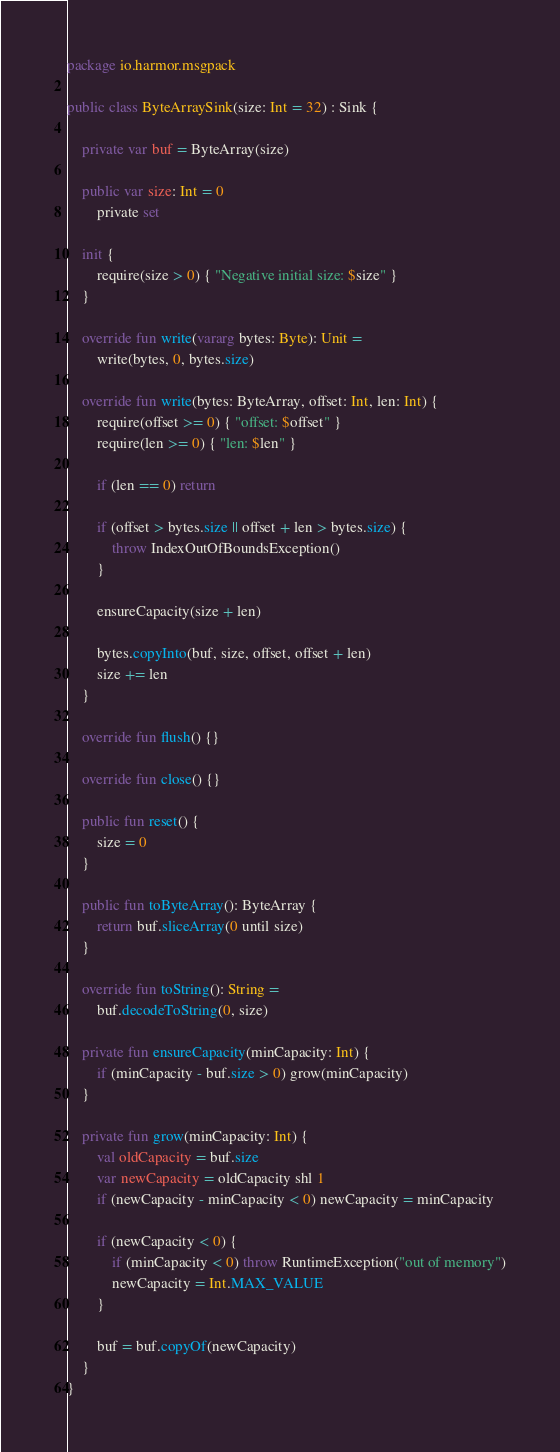<code> <loc_0><loc_0><loc_500><loc_500><_Kotlin_>package io.harmor.msgpack

public class ByteArraySink(size: Int = 32) : Sink {

    private var buf = ByteArray(size)

    public var size: Int = 0
        private set

    init {
        require(size > 0) { "Negative initial size: $size" }
    }

    override fun write(vararg bytes: Byte): Unit =
        write(bytes, 0, bytes.size)

    override fun write(bytes: ByteArray, offset: Int, len: Int) {
        require(offset >= 0) { "offset: $offset" }
        require(len >= 0) { "len: $len" }

        if (len == 0) return

        if (offset > bytes.size || offset + len > bytes.size) {
            throw IndexOutOfBoundsException()
        }

        ensureCapacity(size + len)

        bytes.copyInto(buf, size, offset, offset + len)
        size += len
    }

    override fun flush() {}

    override fun close() {}

    public fun reset() {
        size = 0
    }

    public fun toByteArray(): ByteArray {
        return buf.sliceArray(0 until size)
    }

    override fun toString(): String =
        buf.decodeToString(0, size)

    private fun ensureCapacity(minCapacity: Int) {
        if (minCapacity - buf.size > 0) grow(minCapacity)
    }

    private fun grow(minCapacity: Int) {
        val oldCapacity = buf.size
        var newCapacity = oldCapacity shl 1
        if (newCapacity - minCapacity < 0) newCapacity = minCapacity

        if (newCapacity < 0) {
            if (minCapacity < 0) throw RuntimeException("out of memory")
            newCapacity = Int.MAX_VALUE
        }

        buf = buf.copyOf(newCapacity)
    }
}</code> 